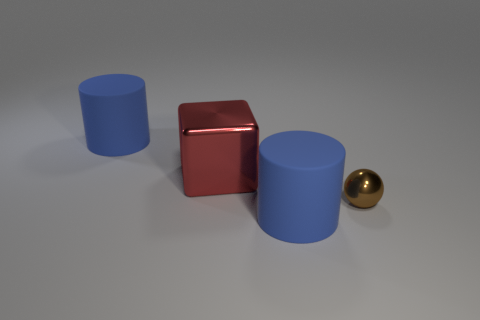Add 2 small cyan shiny cylinders. How many objects exist? 6 Subtract all cubes. How many objects are left? 3 Add 3 big blue cylinders. How many big blue cylinders exist? 5 Subtract 0 green cylinders. How many objects are left? 4 Subtract all small gray rubber blocks. Subtract all red metal objects. How many objects are left? 3 Add 3 red objects. How many red objects are left? 4 